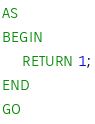Convert code to text. <code><loc_0><loc_0><loc_500><loc_500><_SQL_>AS     
BEGIN
    RETURN 1;
END
GO</code> 